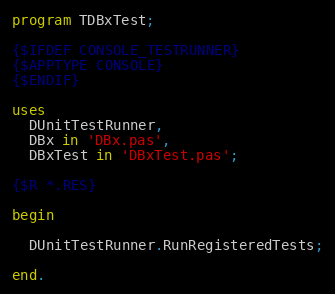Convert code to text. <code><loc_0><loc_0><loc_500><loc_500><_Pascal_>program TDBxTest;

{$IFDEF CONSOLE_TESTRUNNER}
{$APPTYPE CONSOLE}
{$ENDIF}

uses
  DUnitTestRunner,
  DBx in 'DBx.pas',
  DBxTest in 'DBxTest.pas';

{$R *.RES}

begin

  DUnitTestRunner.RunRegisteredTests;

end.
</code> 